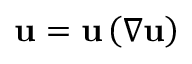<formula> <loc_0><loc_0><loc_500><loc_500>u = u \left ( \nabla u \right )</formula> 